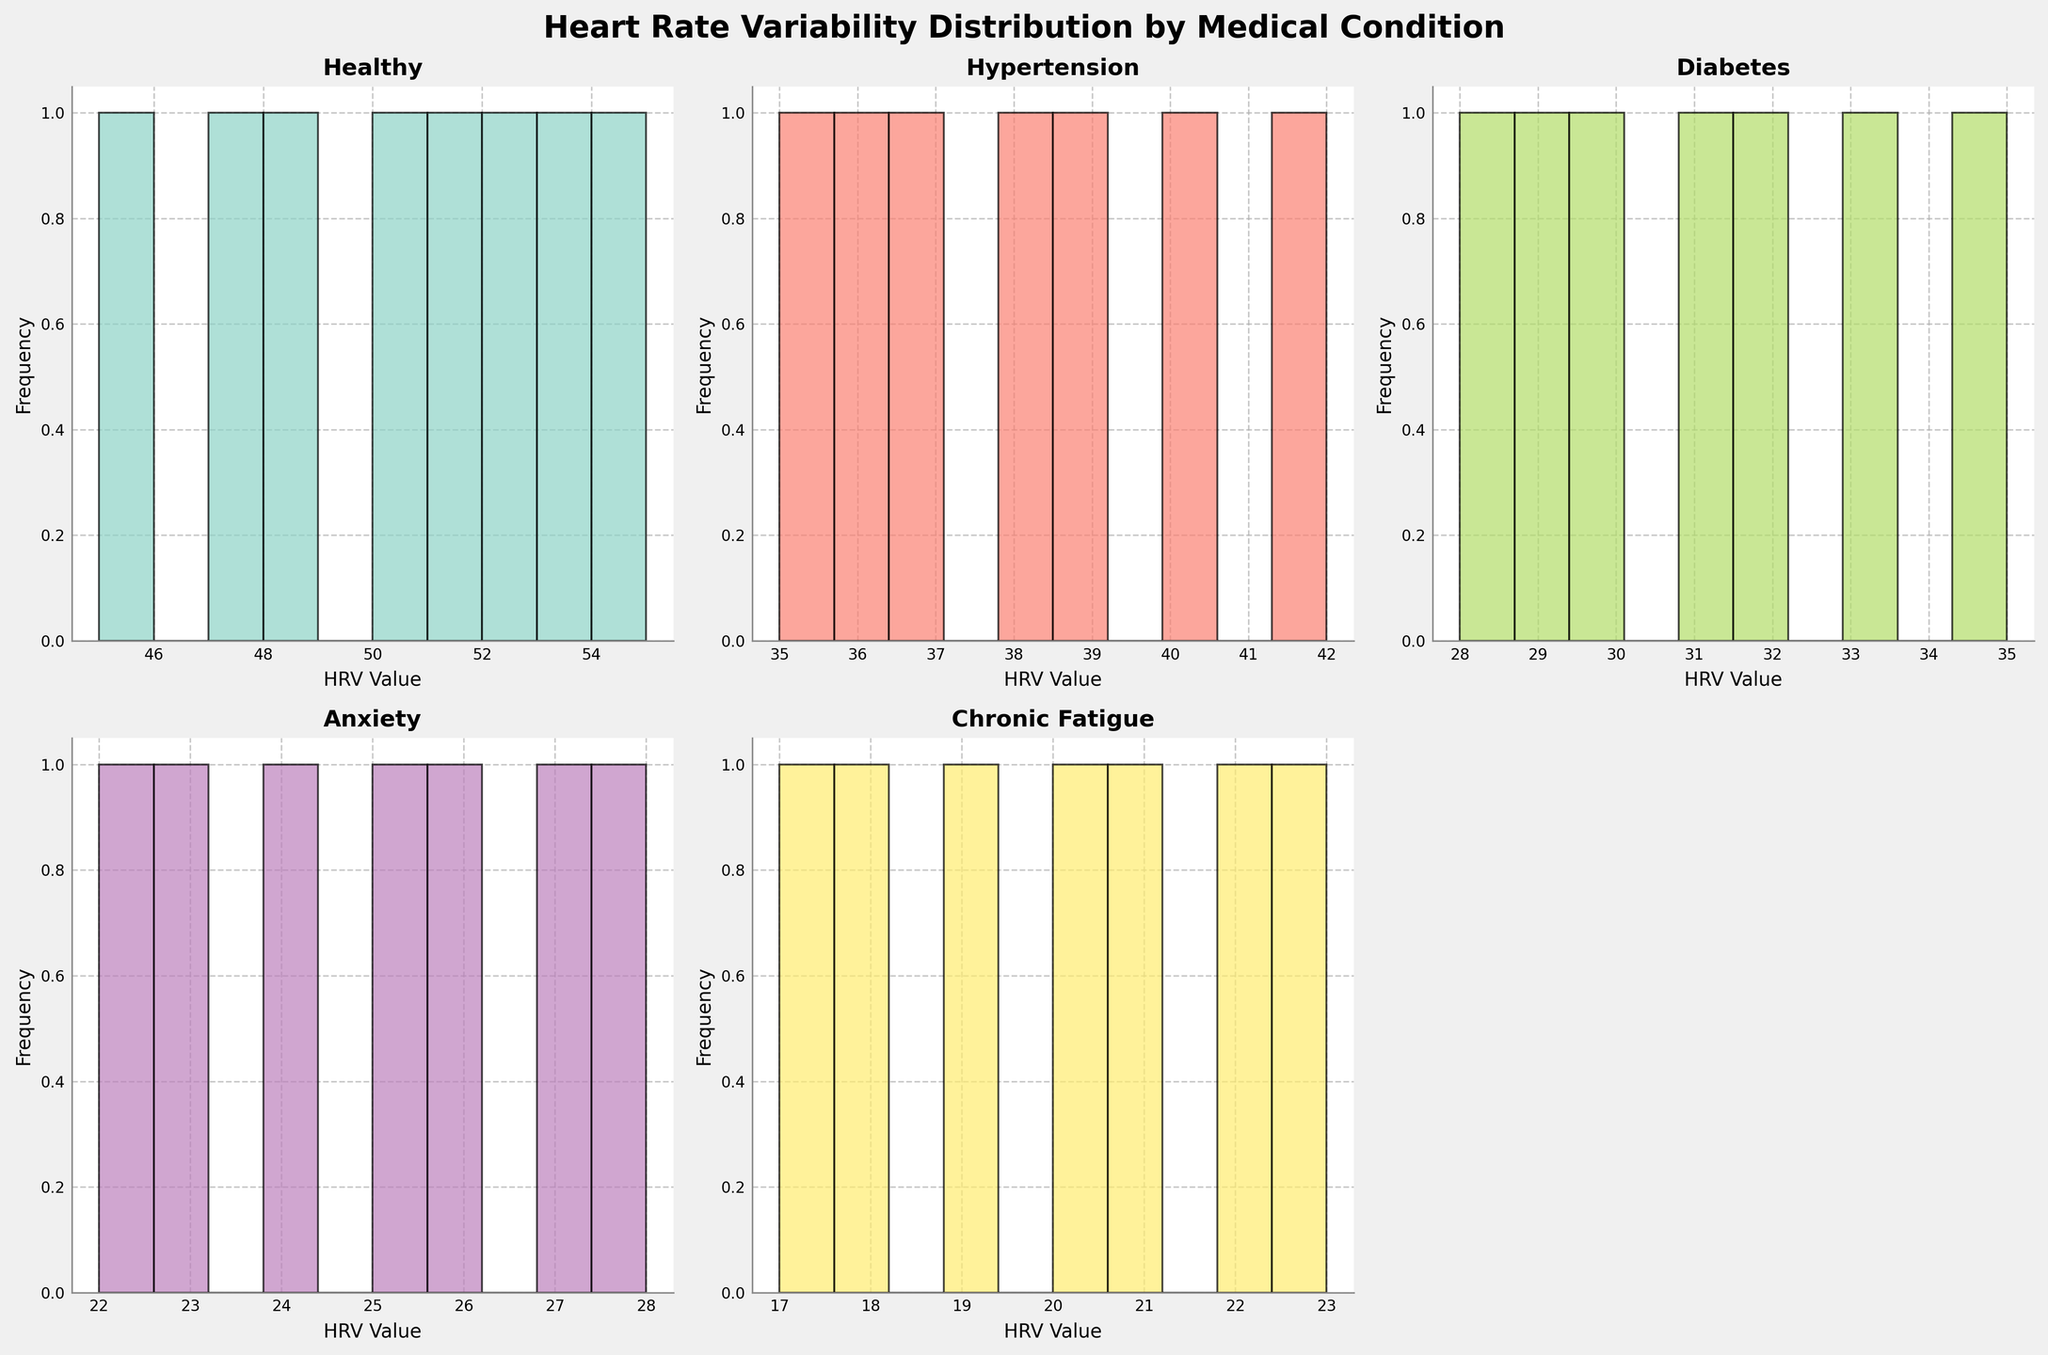What medical condition has the highest HRV values on average? By inspecting the histograms, we can visually estimate that the healthy condition has the highest HRV values on average compared to the other conditions.
Answer: Healthy How many subplots are in the figure? There are six positions for subplots in the 2x3 grid, but some positions may be empty if there are fewer than six conditions. For this figure, there are a total of 5 subplots based on the data provided.
Answer: 5 Which condition shows the lowest range of HRV values? By comparing the histograms, we notice that the Chronic Fatigue condition has the lowest HRV values ranging from 17 to 23. Therefore, its range is the lowest.
Answer: Chronic Fatigue Which condition has the broadest range of HRV values? To determine the broadest range, we can visually assess each histogram and find the difference between the maximum and minimum HRV values. The Healthy condition ranges from 45 to 55, giving it a range of 10, which is the broadest among the conditions shown.
Answer: Healthy What is the central tendency (mean) for the Hypertension group approximately? By looking at the histogram for Hypertension, most values cluster around the 36-40 range. Estimating the central values in the cluster, we can average them as roughly (38 + 35 + 42 + 39 + 36 + 40 + 37)/7, giving approximately 38.
Answer: 38 Which histogram shows that HRV values are most closely clustered together? The Chronic Fatigue subplot shows HRV values most closely clustered together, with most values between 17 and 23, indicating a tight distribution.
Answer: Chronic Fatigue Is there a gap in the HRV values for the Diabetes condition? In the Diabetes histogram, we can see a slight gap around the HRV values of 33-34.
Answer: Yes How can you describe the HRV value distribution for Anxiety? The Anxiety condition shows a fairly clustered distribution of HRV values primarily between 22 to 28, indicating a clustered but slightly broader range than Chronic Fatigue.
Answer: Clustered between 22-28 Which two conditions have the closest HRV distributions based on their histograms? When comparing the histograms, Hypertension and Diabetes conditions have relatively similar HRV distributions. Both conditions' HRV values fall within nearby ranges, between 35-42 for Hypertension and 28-35 for Diabetes, though there is some overlap in their upper bounds.
Answer: Hypertension and Diabetes What is the title of the figure? The title of the figure is given as "Heart Rate Variability Distribution by Medical Condition" at the top of the plot.
Answer: Heart Rate Variability Distribution by Medical Condition 